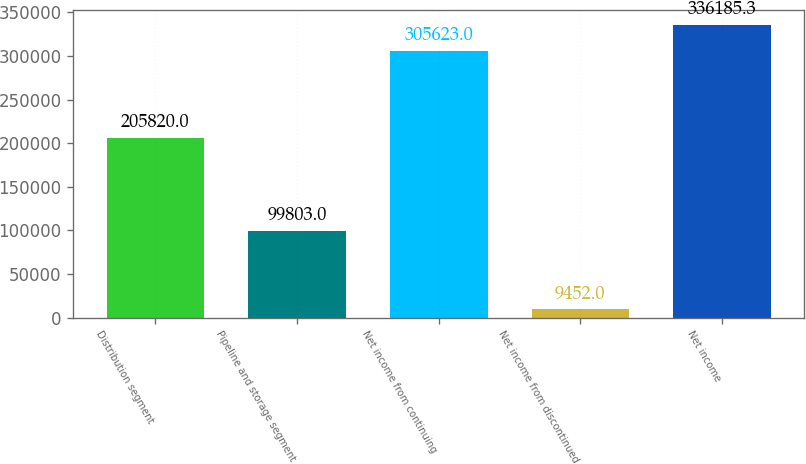<chart> <loc_0><loc_0><loc_500><loc_500><bar_chart><fcel>Distribution segment<fcel>Pipeline and storage segment<fcel>Net income from continuing<fcel>Net income from discontinued<fcel>Net income<nl><fcel>205820<fcel>99803<fcel>305623<fcel>9452<fcel>336185<nl></chart> 